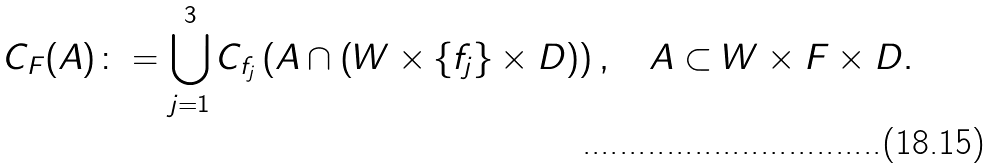<formula> <loc_0><loc_0><loc_500><loc_500>C _ { F } ( A ) \colon = \bigcup _ { j = 1 } ^ { 3 } C _ { f _ { j } } \left ( A \cap ( W \times \{ f _ { j } \} \times D ) \right ) , \quad A \subset W \times F \times D .</formula> 